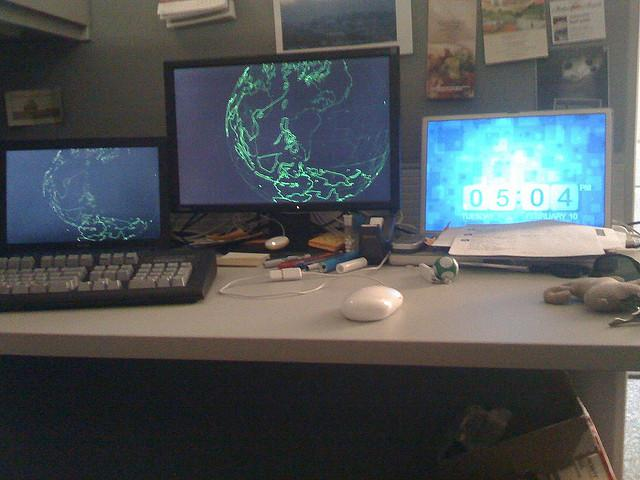What does the white mouse on the table do?

Choices:
A) control computers
B) food
C) listening device
D) glasses control computers 